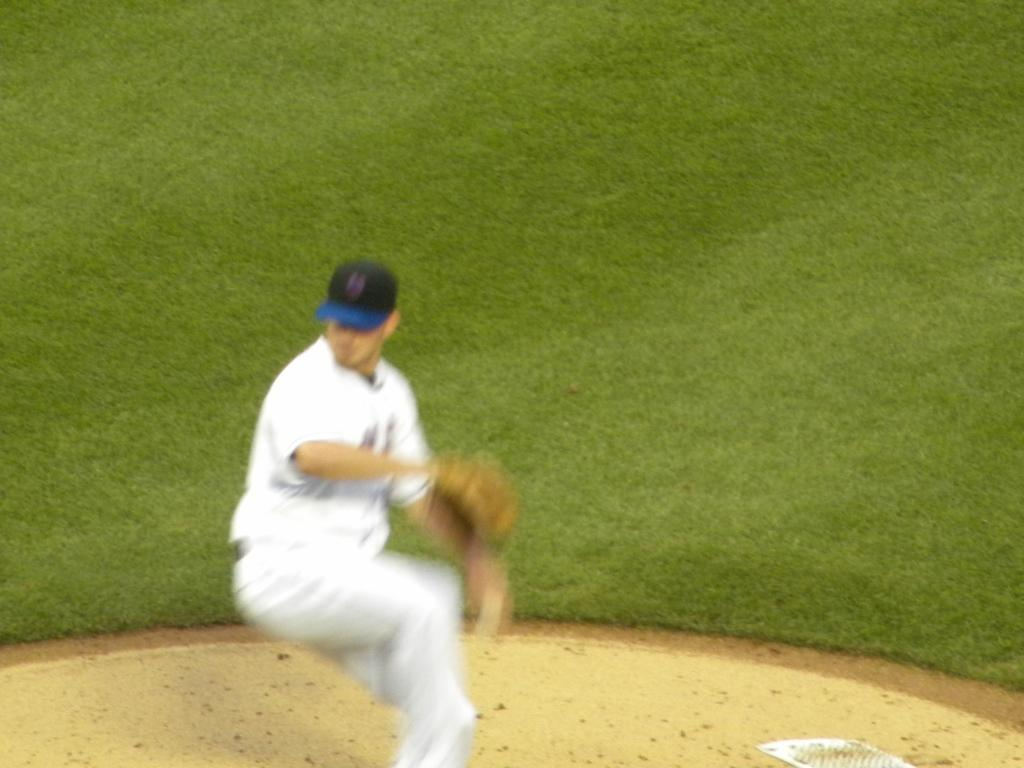Who or what is present in the image? There is a person in the image. What is the person wearing on their head? The person is wearing a cap. What type of surface is visible at the bottom of the image? There is grass on the surface at the bottom of the image. What trail does the person leave behind as they smash through the grass in the image? There is no indication in the image that the person is smashing through the grass or leaving a trail behind. 